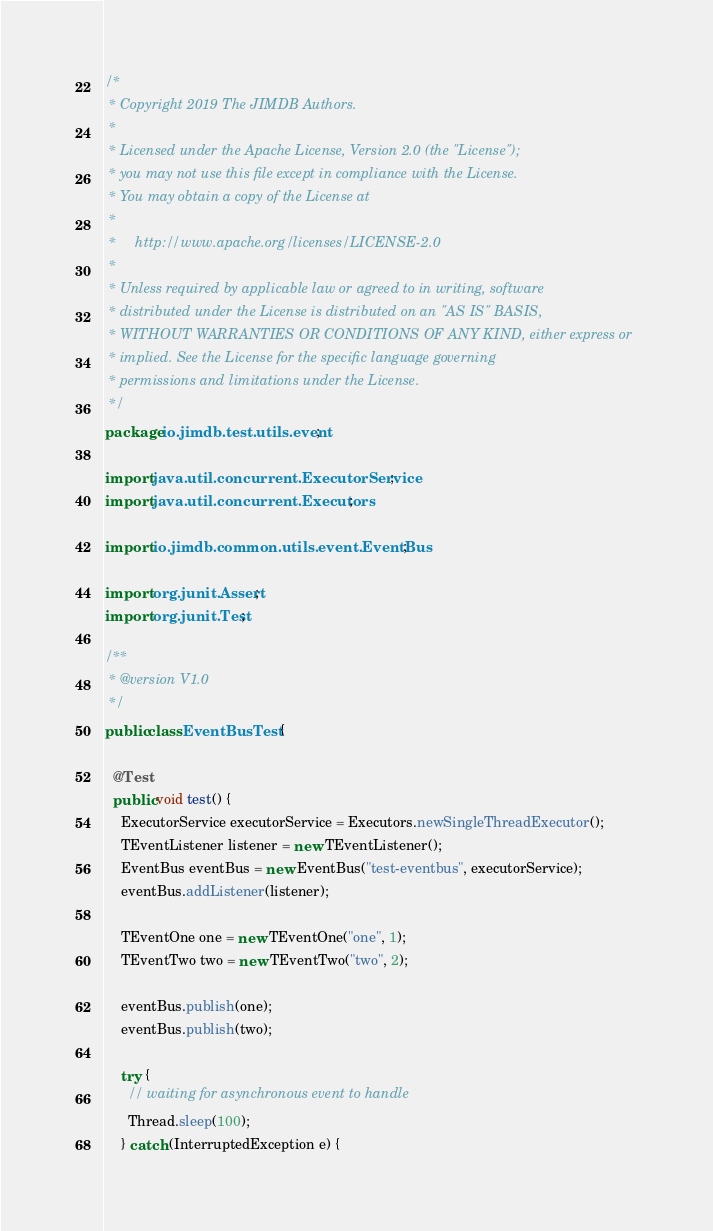<code> <loc_0><loc_0><loc_500><loc_500><_Java_>/*
 * Copyright 2019 The JIMDB Authors.
 *
 * Licensed under the Apache License, Version 2.0 (the "License");
 * you may not use this file except in compliance with the License.
 * You may obtain a copy of the License at
 *
 *     http://www.apache.org/licenses/LICENSE-2.0
 *
 * Unless required by applicable law or agreed to in writing, software
 * distributed under the License is distributed on an "AS IS" BASIS,
 * WITHOUT WARRANTIES OR CONDITIONS OF ANY KIND, either express or
 * implied. See the License for the specific language governing
 * permissions and limitations under the License.
 */
package io.jimdb.test.utils.event;

import java.util.concurrent.ExecutorService;
import java.util.concurrent.Executors;

import io.jimdb.common.utils.event.EventBus;

import org.junit.Assert;
import org.junit.Test;

/**
 * @version V1.0
 */
public class EventBusTest {

  @Test
  public void test() {
    ExecutorService executorService = Executors.newSingleThreadExecutor();
    TEventListener listener = new TEventListener();
    EventBus eventBus = new EventBus("test-eventbus", executorService);
    eventBus.addListener(listener);

    TEventOne one = new TEventOne("one", 1);
    TEventTwo two = new TEventTwo("two", 2);

    eventBus.publish(one);
    eventBus.publish(two);

    try {
      // waiting for asynchronous event to handle
      Thread.sleep(100);
    } catch (InterruptedException e) {</code> 